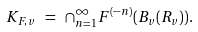<formula> <loc_0><loc_0><loc_500><loc_500>K _ { F , v } \ = \ \cap _ { n = 1 } ^ { \infty } F ^ { ( - n ) } ( B _ { v } ( R _ { v } ) ) .</formula> 